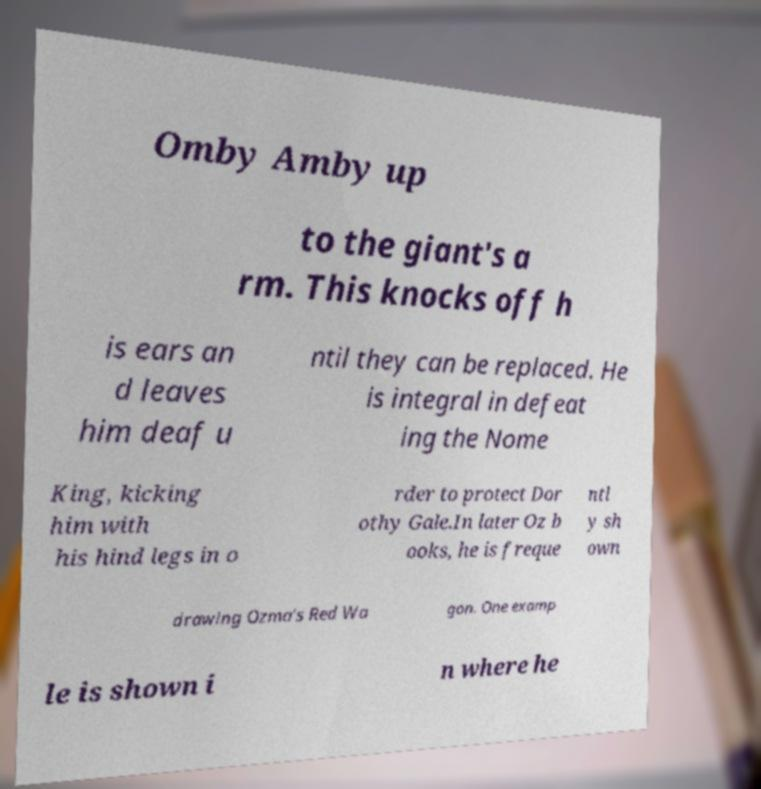For documentation purposes, I need the text within this image transcribed. Could you provide that? Omby Amby up to the giant's a rm. This knocks off h is ears an d leaves him deaf u ntil they can be replaced. He is integral in defeat ing the Nome King, kicking him with his hind legs in o rder to protect Dor othy Gale.In later Oz b ooks, he is freque ntl y sh own drawing Ozma's Red Wa gon. One examp le is shown i n where he 